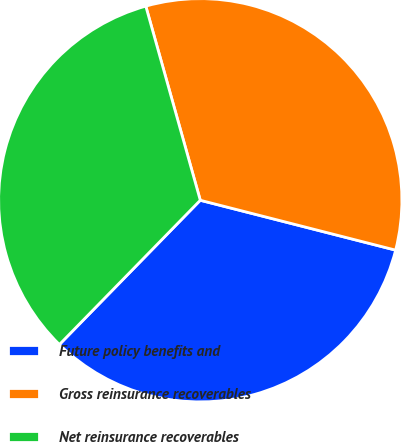<chart> <loc_0><loc_0><loc_500><loc_500><pie_chart><fcel>Future policy benefits and<fcel>Gross reinsurance recoverables<fcel>Net reinsurance recoverables<nl><fcel>33.33%<fcel>33.33%<fcel>33.33%<nl></chart> 